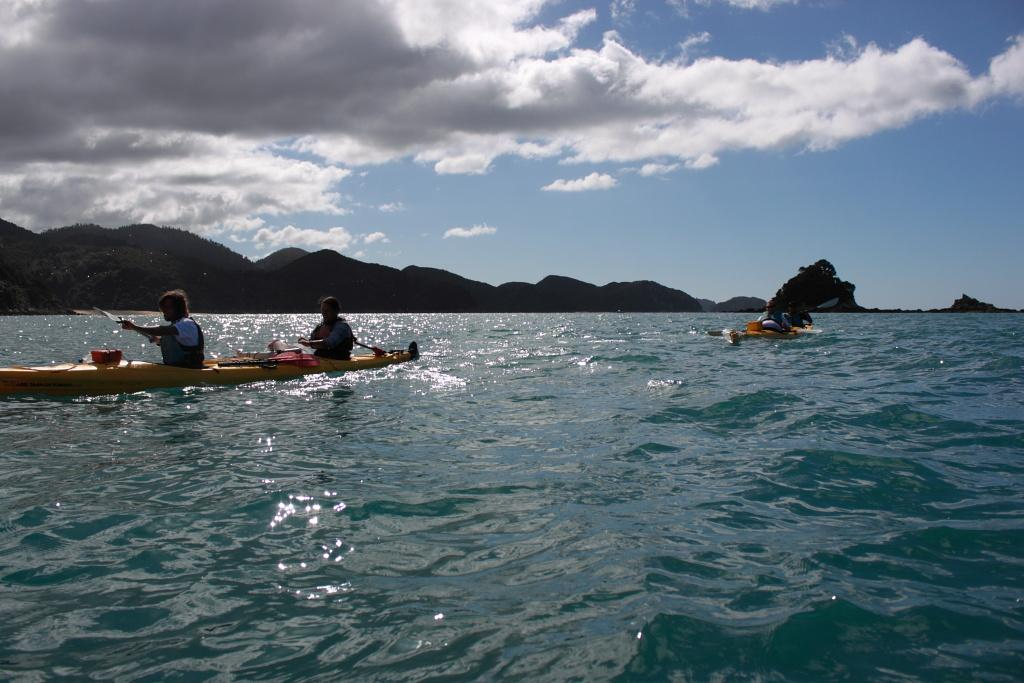What are the people in the image doing? There are persons sitting on a boat in the image. What is the boat doing in the image? The boat is moving on water in the image. What can be seen in the background of the image? There are mountains visible in the background of the image, and the sky is sunny. What type of arm is visible in the image? There is no arm present in the image; it features persons sitting on a boat and the surrounding environment. 